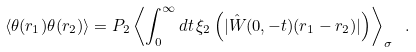<formula> <loc_0><loc_0><loc_500><loc_500>\langle \theta ( { r } _ { 1 } ) \theta ( { r } _ { 2 } ) \rangle = P _ { 2 } \left \langle \int _ { 0 } ^ { \infty } d t \, \xi _ { 2 } \left ( | \hat { W } ( 0 , - t ) ( { r } _ { 1 } - { r } _ { 2 } ) | \right ) \right \rangle _ { \sigma } \ .</formula> 